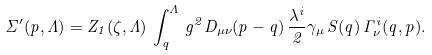<formula> <loc_0><loc_0><loc_500><loc_500>\Sigma ^ { \prime } ( p , \Lambda ) = Z _ { 1 } ( \zeta , \Lambda ) \, \int ^ { \Lambda } _ { q } \, g ^ { 2 } D _ { \mu \nu } ( p - q ) \, \frac { \lambda ^ { i } } { 2 } \gamma _ { \mu } \, S ( q ) \, \Gamma ^ { i } _ { \nu } ( q , p ) .</formula> 